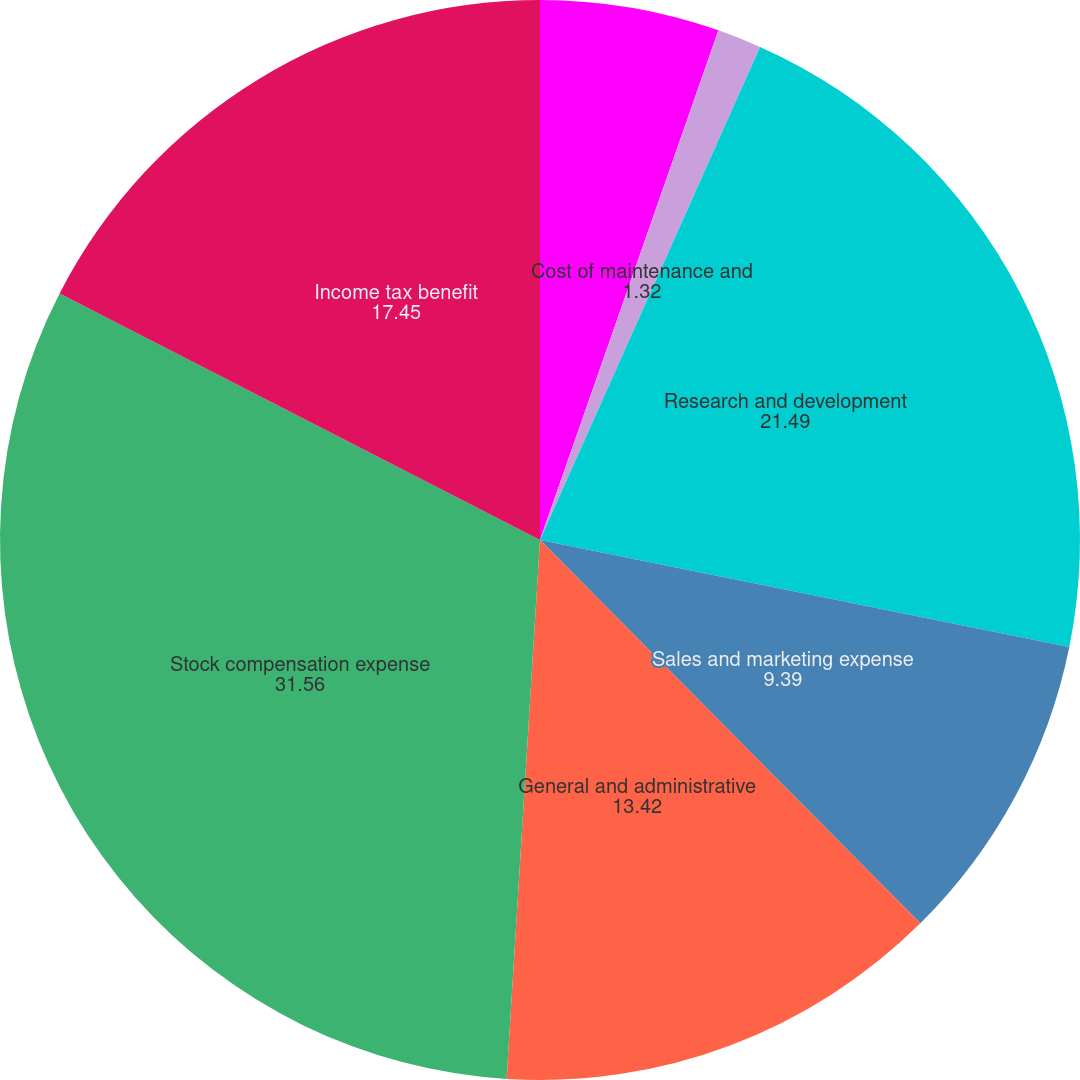Convert chart. <chart><loc_0><loc_0><loc_500><loc_500><pie_chart><fcel>Cost of license<fcel>Cost of maintenance and<fcel>Research and development<fcel>Sales and marketing expense<fcel>General and administrative<fcel>Stock compensation expense<fcel>Income tax benefit<nl><fcel>5.36%<fcel>1.32%<fcel>21.49%<fcel>9.39%<fcel>13.42%<fcel>31.56%<fcel>17.45%<nl></chart> 